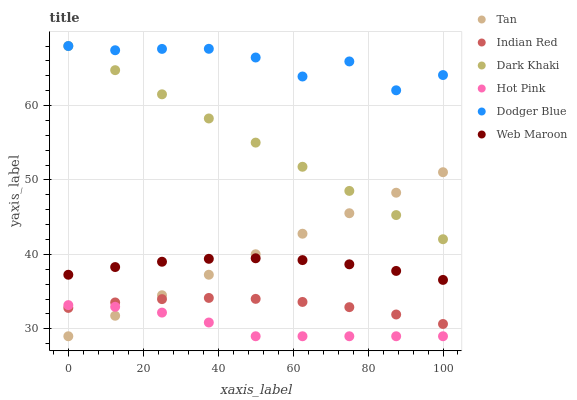Does Hot Pink have the minimum area under the curve?
Answer yes or no. Yes. Does Dodger Blue have the maximum area under the curve?
Answer yes or no. Yes. Does Web Maroon have the minimum area under the curve?
Answer yes or no. No. Does Web Maroon have the maximum area under the curve?
Answer yes or no. No. Is Dark Khaki the smoothest?
Answer yes or no. Yes. Is Dodger Blue the roughest?
Answer yes or no. Yes. Is Web Maroon the smoothest?
Answer yes or no. No. Is Web Maroon the roughest?
Answer yes or no. No. Does Hot Pink have the lowest value?
Answer yes or no. Yes. Does Web Maroon have the lowest value?
Answer yes or no. No. Does Dodger Blue have the highest value?
Answer yes or no. Yes. Does Web Maroon have the highest value?
Answer yes or no. No. Is Indian Red less than Dodger Blue?
Answer yes or no. Yes. Is Web Maroon greater than Hot Pink?
Answer yes or no. Yes. Does Indian Red intersect Hot Pink?
Answer yes or no. Yes. Is Indian Red less than Hot Pink?
Answer yes or no. No. Is Indian Red greater than Hot Pink?
Answer yes or no. No. Does Indian Red intersect Dodger Blue?
Answer yes or no. No. 